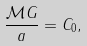<formula> <loc_0><loc_0><loc_500><loc_500>\frac { \mathcal { M } G } { a } = C _ { 0 } ,</formula> 